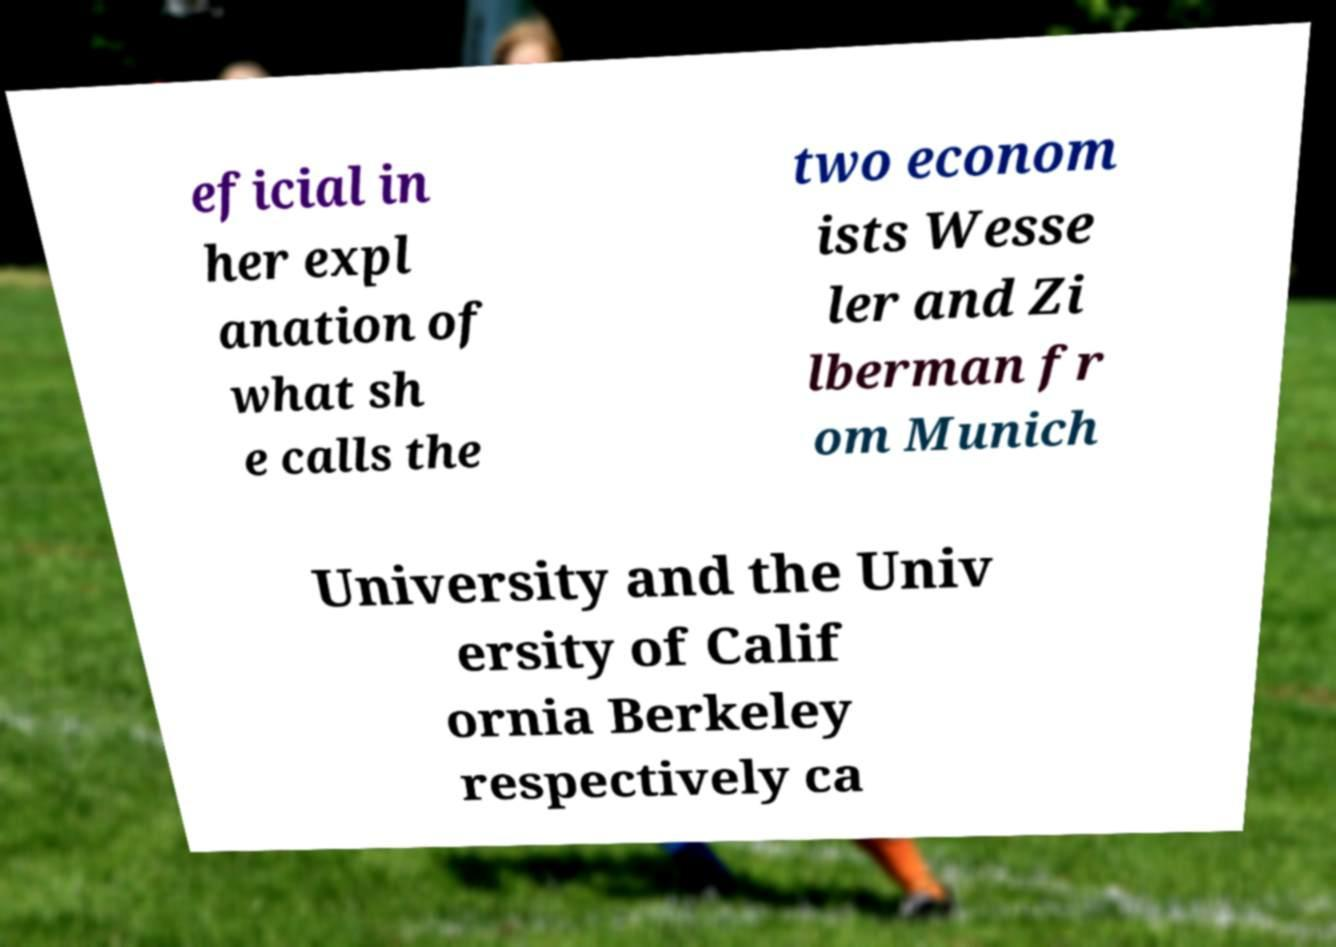I need the written content from this picture converted into text. Can you do that? eficial in her expl anation of what sh e calls the two econom ists Wesse ler and Zi lberman fr om Munich University and the Univ ersity of Calif ornia Berkeley respectively ca 